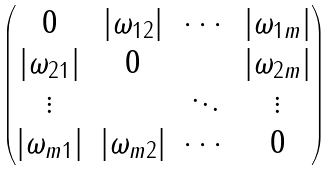Convert formula to latex. <formula><loc_0><loc_0><loc_500><loc_500>\begin{pmatrix} 0 & | \omega _ { 1 2 } | & \cdots & | \omega _ { 1 m } | \\ | \omega _ { 2 1 } | & 0 & & | \omega _ { 2 m } | \\ \vdots & & \ddots & \vdots \\ | \omega _ { m 1 } | & | \omega _ { m 2 } | & \cdots & 0 \end{pmatrix}</formula> 